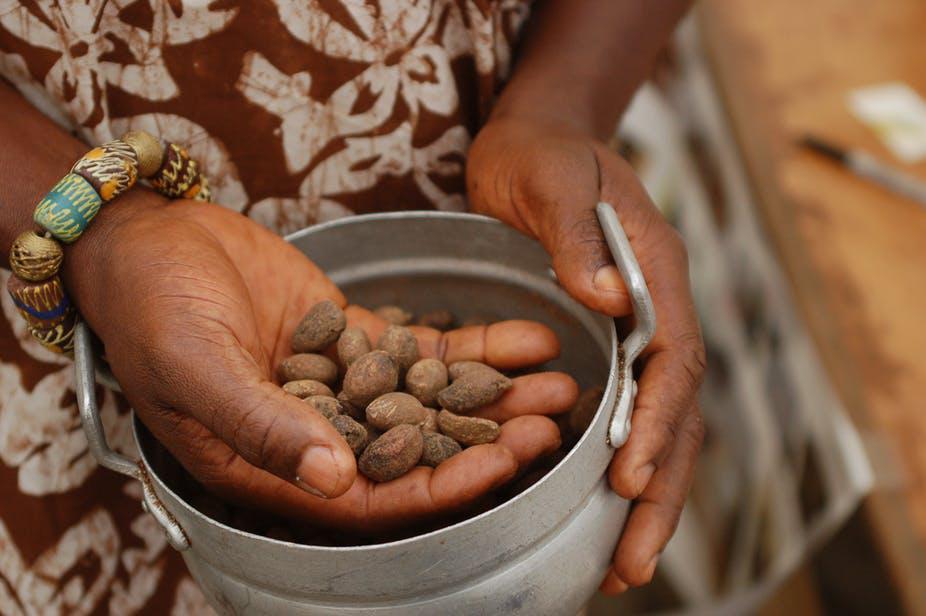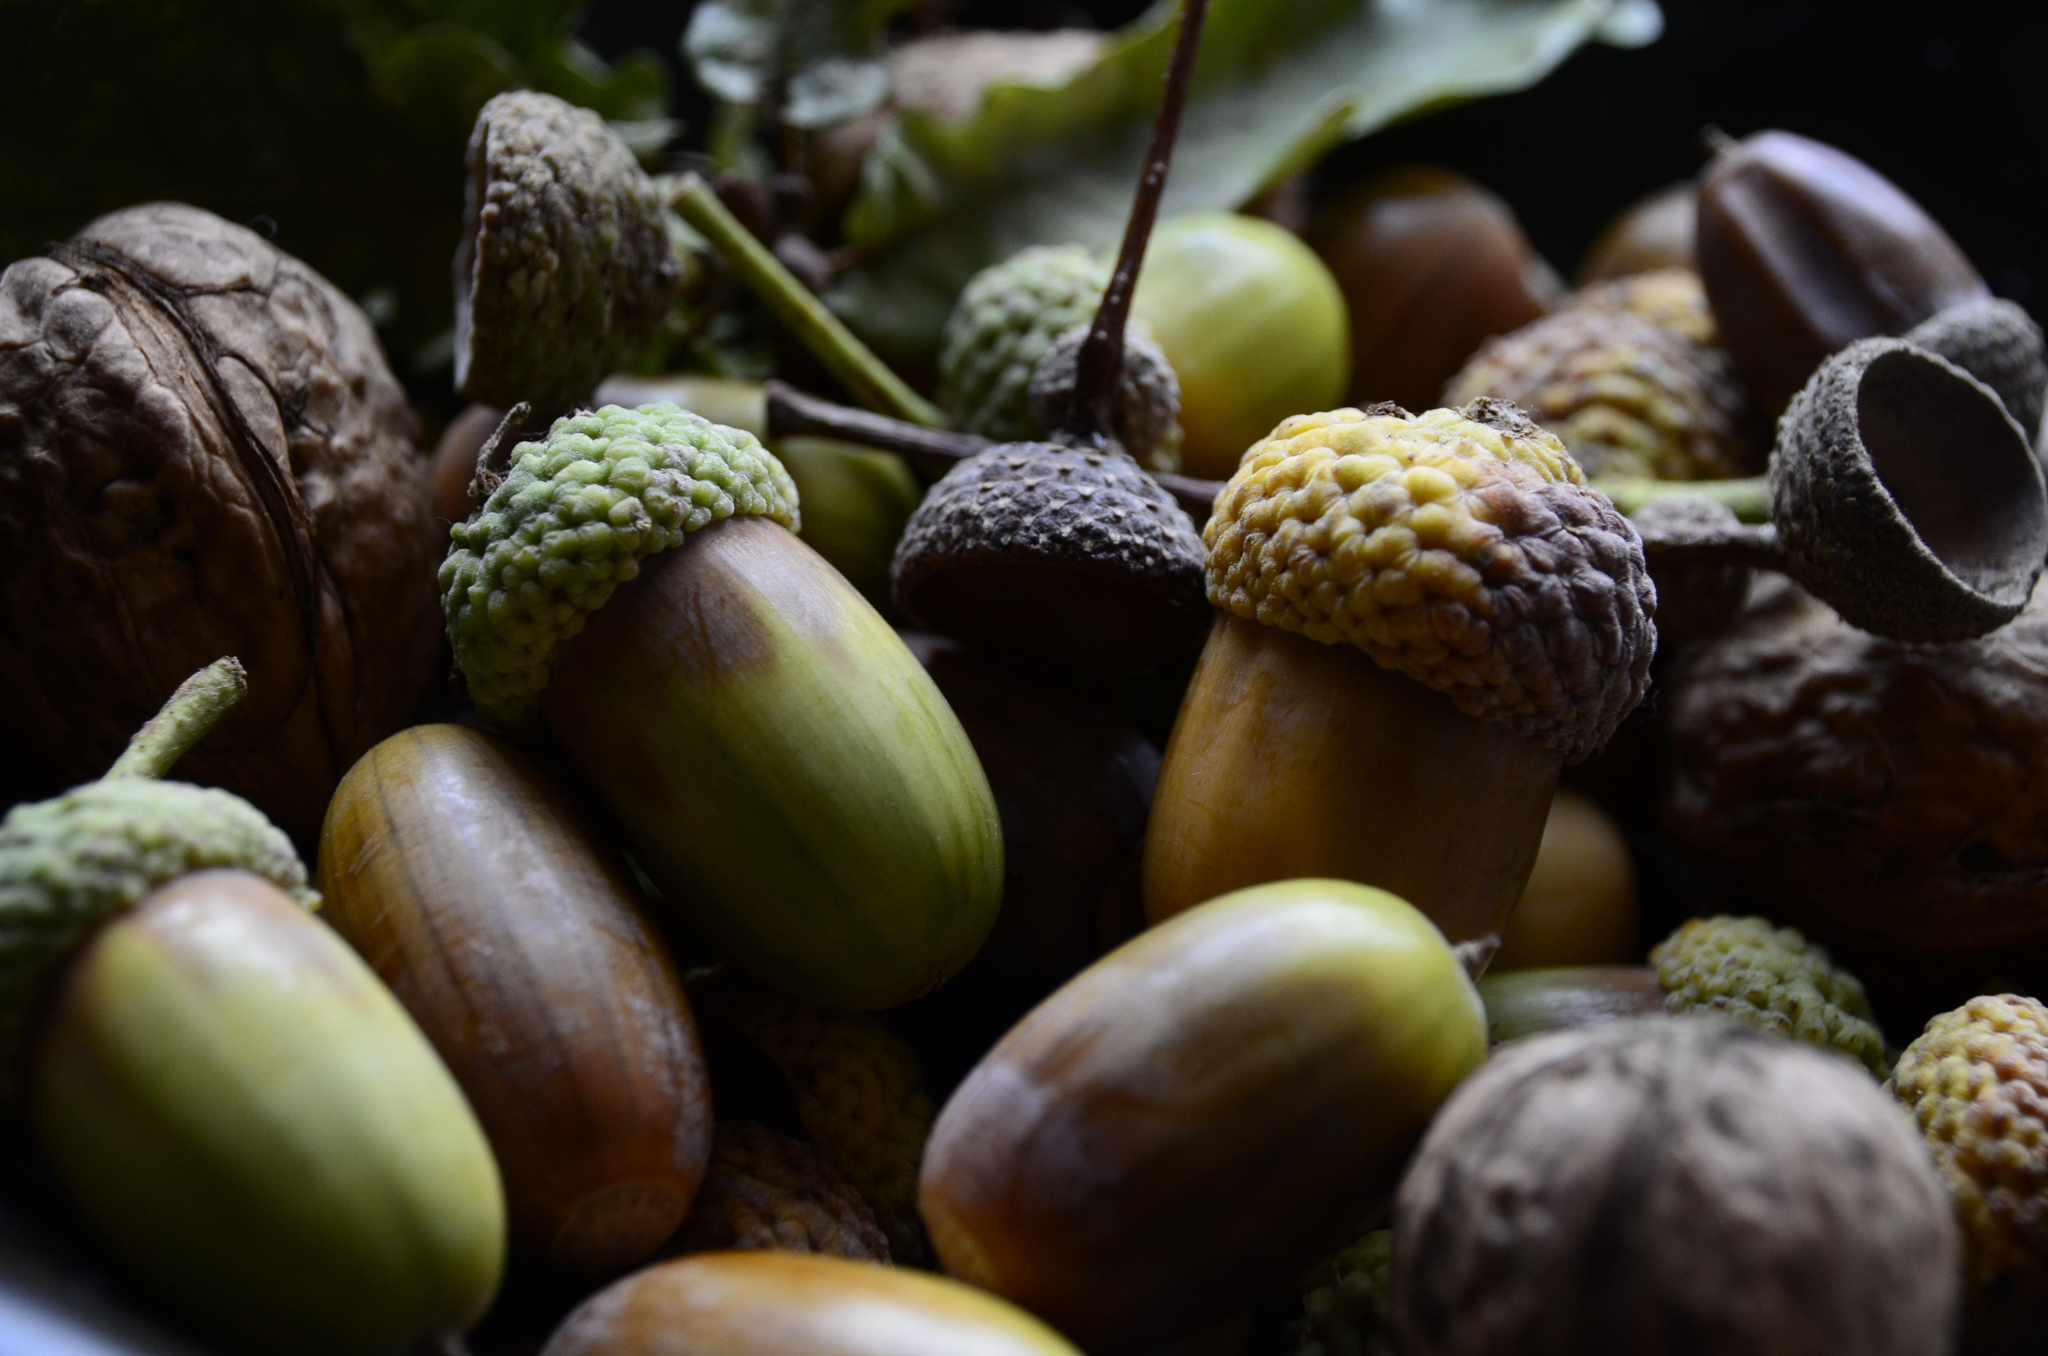The first image is the image on the left, the second image is the image on the right. Assess this claim about the two images: "Each image shows acorns growing on a tree with green leaves, and in total, most acorns are green and most acorns are slender.". Correct or not? Answer yes or no. No. The first image is the image on the left, the second image is the image on the right. For the images displayed, is the sentence "Acorns are growing on trees in each of the images." factually correct? Answer yes or no. No. 